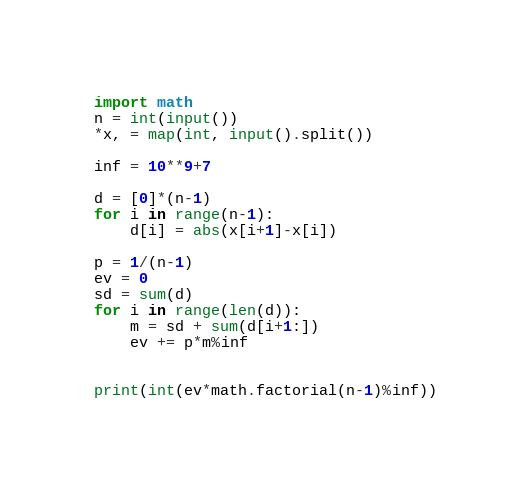Convert code to text. <code><loc_0><loc_0><loc_500><loc_500><_Python_>import math
n = int(input())
*x, = map(int, input().split())

inf = 10**9+7

d = [0]*(n-1)
for i in range(n-1):
    d[i] = abs(x[i+1]-x[i])

p = 1/(n-1)
ev = 0
sd = sum(d)
for i in range(len(d)):
    m = sd + sum(d[i+1:])
    ev += p*m%inf


print(int(ev*math.factorial(n-1)%inf))
</code> 